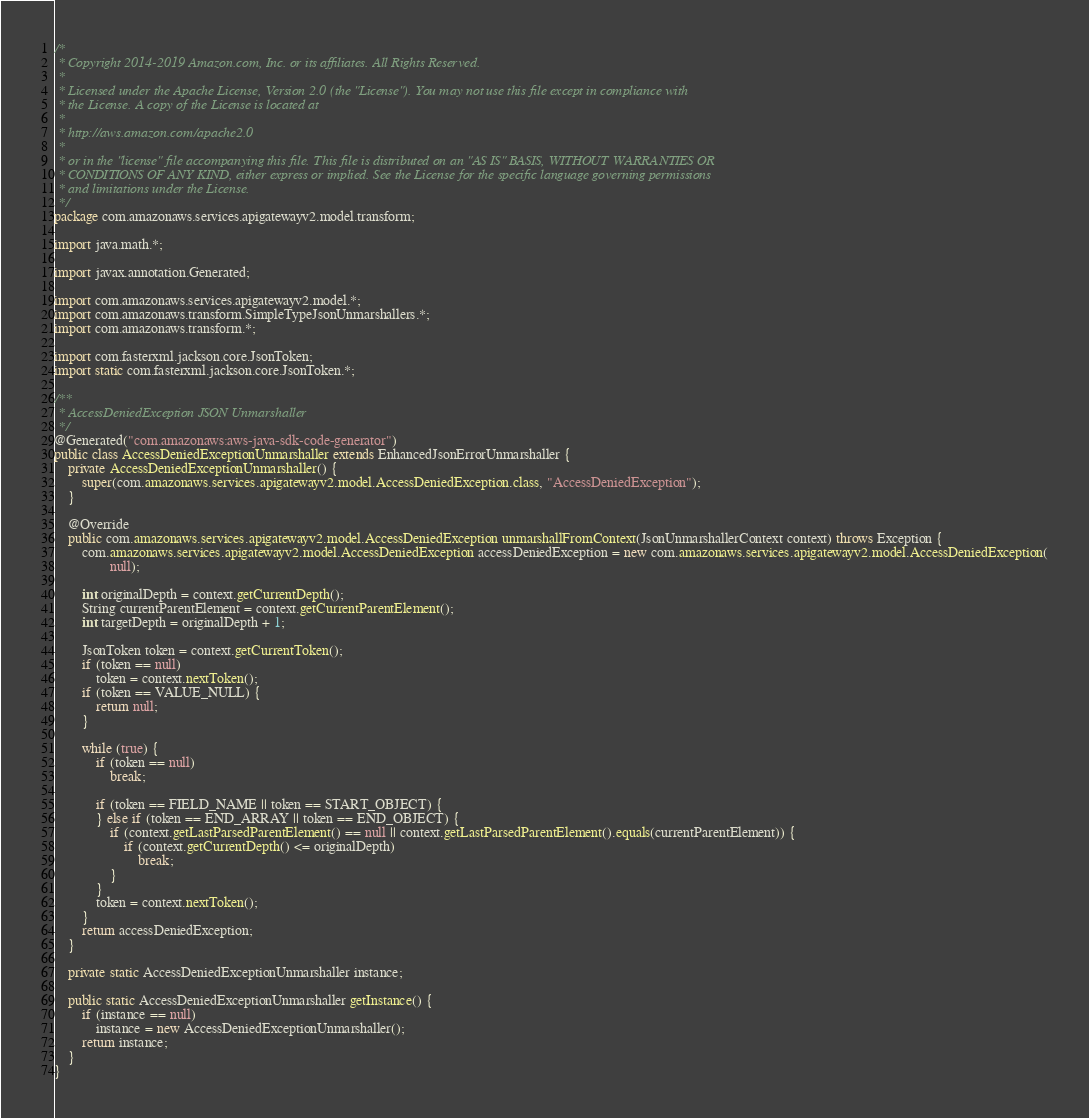Convert code to text. <code><loc_0><loc_0><loc_500><loc_500><_Java_>/*
 * Copyright 2014-2019 Amazon.com, Inc. or its affiliates. All Rights Reserved.
 * 
 * Licensed under the Apache License, Version 2.0 (the "License"). You may not use this file except in compliance with
 * the License. A copy of the License is located at
 * 
 * http://aws.amazon.com/apache2.0
 * 
 * or in the "license" file accompanying this file. This file is distributed on an "AS IS" BASIS, WITHOUT WARRANTIES OR
 * CONDITIONS OF ANY KIND, either express or implied. See the License for the specific language governing permissions
 * and limitations under the License.
 */
package com.amazonaws.services.apigatewayv2.model.transform;

import java.math.*;

import javax.annotation.Generated;

import com.amazonaws.services.apigatewayv2.model.*;
import com.amazonaws.transform.SimpleTypeJsonUnmarshallers.*;
import com.amazonaws.transform.*;

import com.fasterxml.jackson.core.JsonToken;
import static com.fasterxml.jackson.core.JsonToken.*;

/**
 * AccessDeniedException JSON Unmarshaller
 */
@Generated("com.amazonaws:aws-java-sdk-code-generator")
public class AccessDeniedExceptionUnmarshaller extends EnhancedJsonErrorUnmarshaller {
    private AccessDeniedExceptionUnmarshaller() {
        super(com.amazonaws.services.apigatewayv2.model.AccessDeniedException.class, "AccessDeniedException");
    }

    @Override
    public com.amazonaws.services.apigatewayv2.model.AccessDeniedException unmarshallFromContext(JsonUnmarshallerContext context) throws Exception {
        com.amazonaws.services.apigatewayv2.model.AccessDeniedException accessDeniedException = new com.amazonaws.services.apigatewayv2.model.AccessDeniedException(
                null);

        int originalDepth = context.getCurrentDepth();
        String currentParentElement = context.getCurrentParentElement();
        int targetDepth = originalDepth + 1;

        JsonToken token = context.getCurrentToken();
        if (token == null)
            token = context.nextToken();
        if (token == VALUE_NULL) {
            return null;
        }

        while (true) {
            if (token == null)
                break;

            if (token == FIELD_NAME || token == START_OBJECT) {
            } else if (token == END_ARRAY || token == END_OBJECT) {
                if (context.getLastParsedParentElement() == null || context.getLastParsedParentElement().equals(currentParentElement)) {
                    if (context.getCurrentDepth() <= originalDepth)
                        break;
                }
            }
            token = context.nextToken();
        }
        return accessDeniedException;
    }

    private static AccessDeniedExceptionUnmarshaller instance;

    public static AccessDeniedExceptionUnmarshaller getInstance() {
        if (instance == null)
            instance = new AccessDeniedExceptionUnmarshaller();
        return instance;
    }
}
</code> 